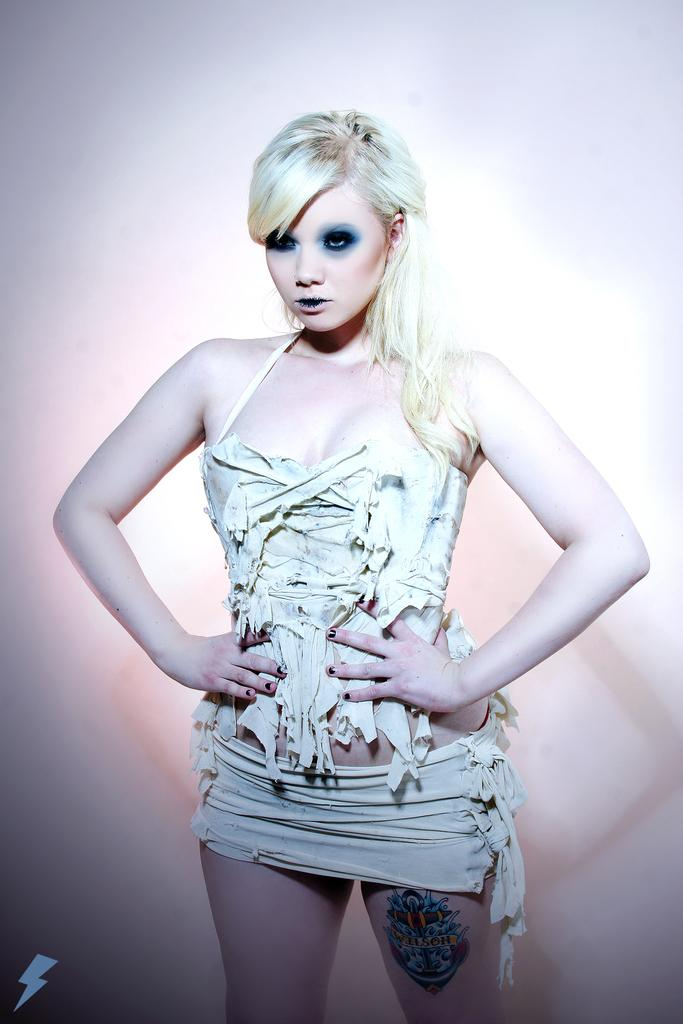Who is the main subject in the image? There is a girl in the image. What is the girl doing in the image? The girl is standing. What is the girl wearing in the image? The girl is wearing a white dress. What is the color of the girl's hair? The girl has blonde hair. What type of paste is the girl using to draw on the chalkboard in the image? There is no chalkboard or paste present in the image; it features a girl standing and wearing a white dress. What kind of plant is growing near the girl in the image? There is no plant visible near the girl in the image. 